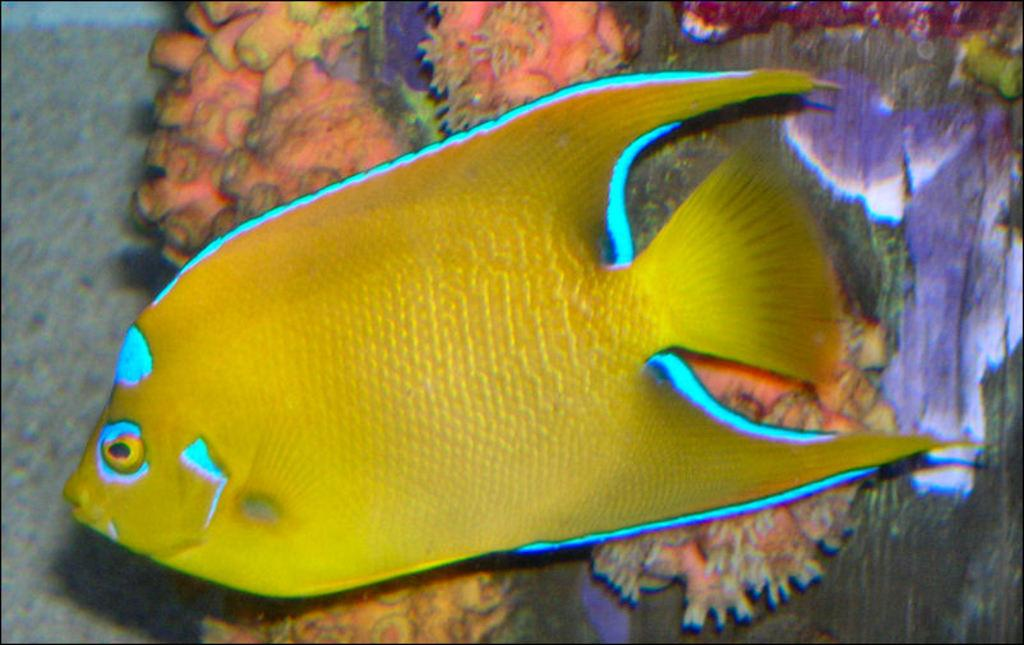What type of animal is present in the image? There is a fish in the image. What else can be seen in the image besides the fish? There are underwater plants in the image. What type of cave can be seen in the image? There is no cave present in the image; it features a fish and underwater plants. What smell is associated with the fish in the image? The image does not convey any smells, so it is not possible to determine the smell associated with the fish. 